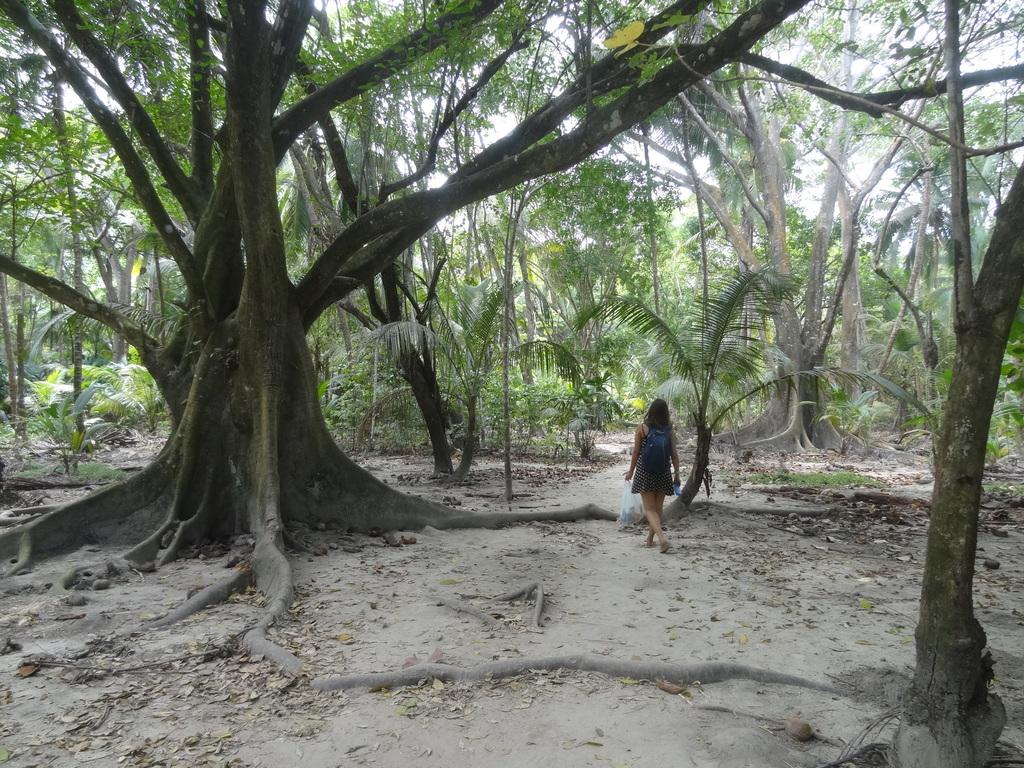Who is the main subject in the image? There is a woman in the image. What is the woman wearing on her back? The woman is wearing a backpack. What is the woman doing in the image? The woman is walking. What can be seen on the ground in the image? Dried leaves are present on the ground. What type of environment is depicted in the image? The image appears to be set in a forest. What can be seen in the front of the image? There are many trees in the front of the image. What type of ornament is hanging from the tree in the image? There is no ornament hanging from the tree in the image; it is set in a forest with many trees. Is there any blood visible on the woman's clothes in the image? There is no blood visible on the woman's clothes in the image; she is simply walking with a backpack. 